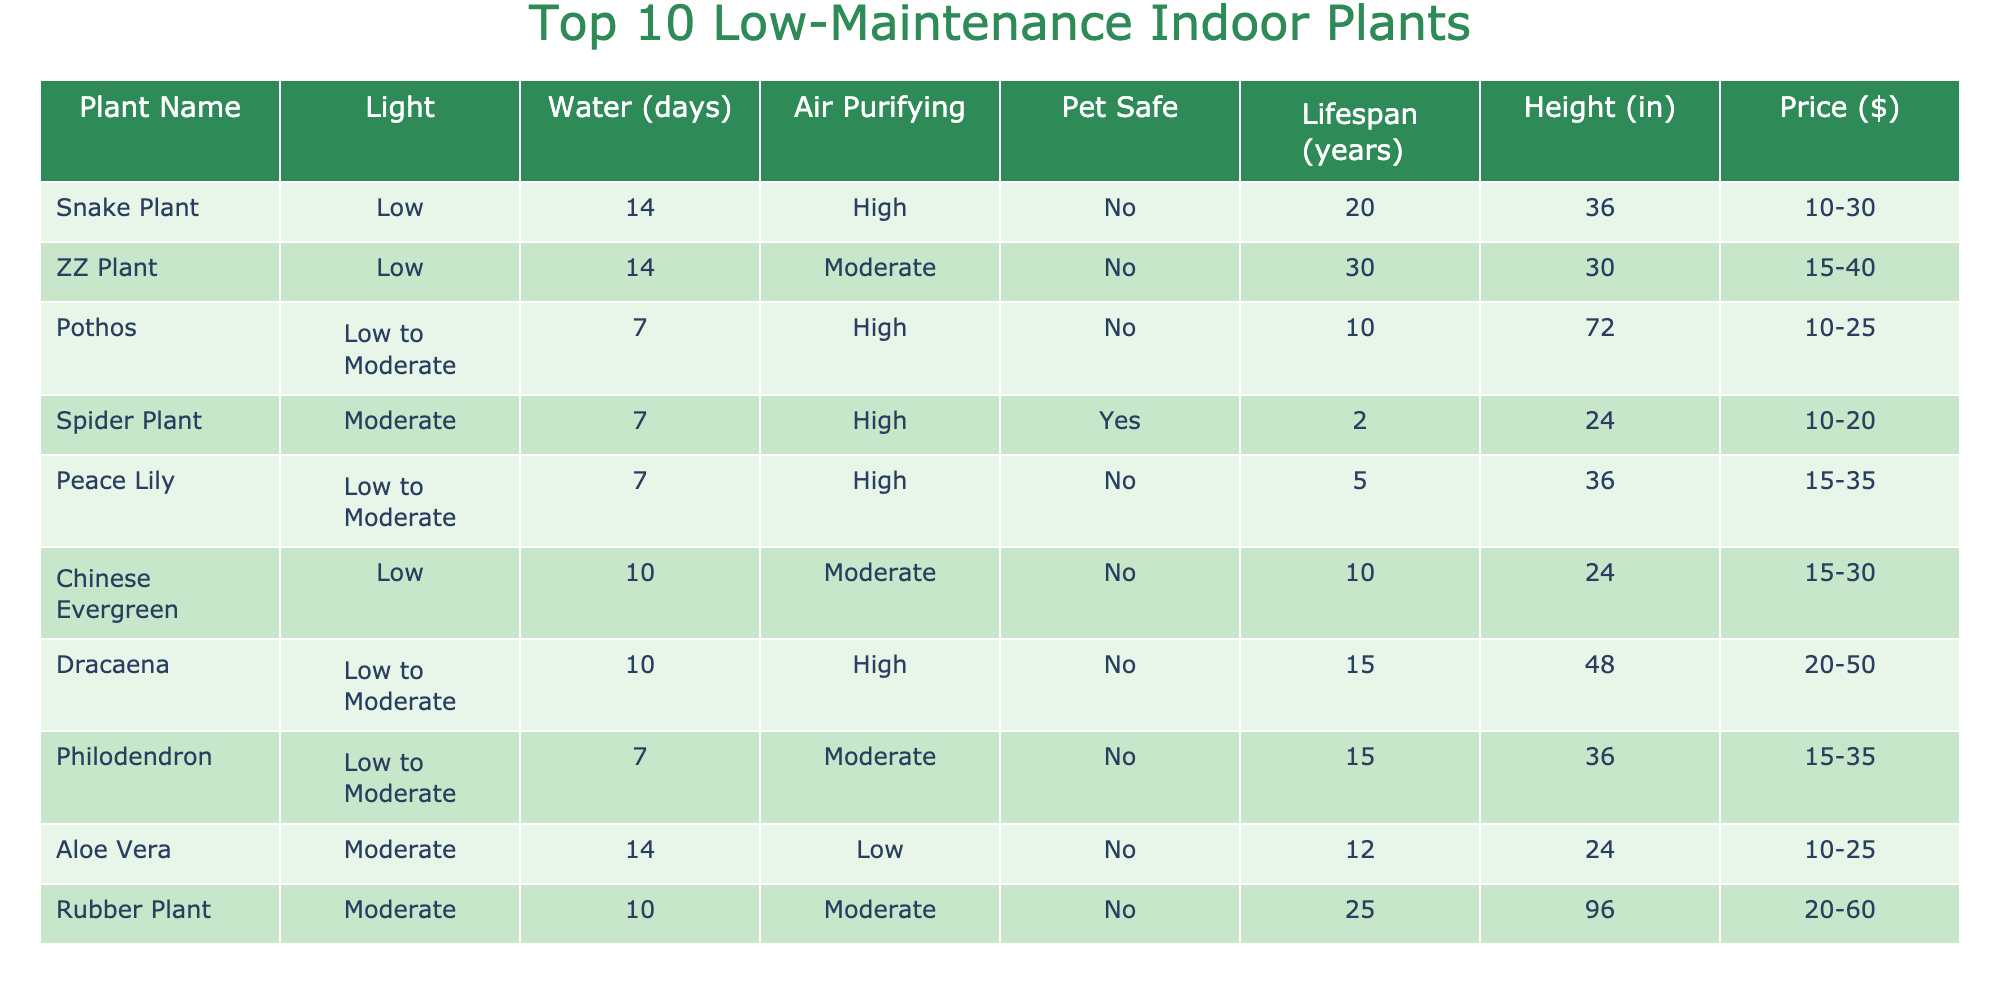What is the lifespan of the ZZ Plant? The table lists the lifespan of the ZZ Plant in the "Lifespan (years)" column, which shows a value of 30 years.
Answer: 30 years How often should you water a Peace Lily? Looking at the "Water Frequency (days)" column, the table indicates that a Peace Lily should be watered every 7 days.
Answer: Every 7 days Is the Spider Plant safe for pets? The table contains a "Pet Safe" column where the Spider Plant is marked as "Yes," indicating that it is safe for pets.
Answer: Yes Which plant has the highest average height? The average heights are listed in the "Avg Height (inches)" column, and by comparing the values, the Rubber Plant has the highest height at 96 inches.
Answer: Rubber Plant What is the average lifespan of the plants listed in the table? To calculate the average lifespan, we sum the lifespans (20 + 30 + 10 + 2 + 5 + 10 + 15 + 15 + 12 + 25 =  139) and divide by the number of plants (10), yielding an average lifespan of 13.9 years.
Answer: 13.9 years How many plants require moderate light? From the "Light Requirement" column, we can identify that 5 plants, specifically Pothos, Peace Lily, Dracaena, Philodendron, and Rubber Plant, require moderate light.
Answer: 5 plants What is the price range for the Snake Plant? The "Price Range ($)" column indicates that the price for a Snake Plant falls between 10 and 30 dollars.
Answer: 10-30 dollars Which plant has the lowest water frequency? By analyzing the "Water Frequency (days)" column, the Snake Plant and ZZ Plant both need to be watered every 14 days, which is the lowest frequency compared to others.
Answer: Snake Plant and ZZ Plant Is Aloe Vera an air-purifying plant? The "Air Purifying" column lists Aloe Vera as "Low," indicating it does not have significant air-purifying qualities.
Answer: No What is the price difference between the cheapest and most expensive plants? The table shows that the cheapest plant (Pothos) ranges from 10 to 25 dollars and the most expensive (Rubber Plant) ranges from 20 to 60 dollars. The price difference calculated from the midpoints (25 - 20 = 5 dollars) is 5 dollars.
Answer: 5 dollars 